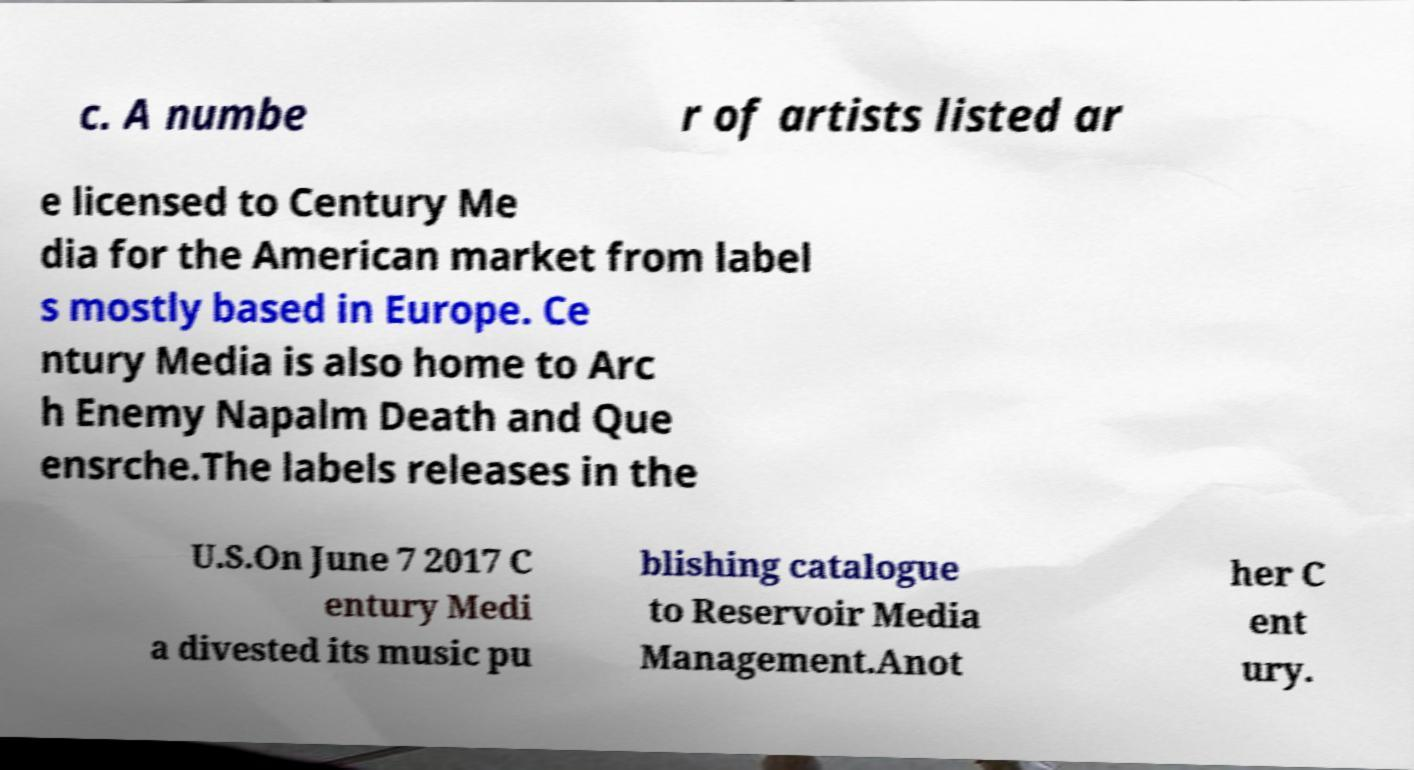Please identify and transcribe the text found in this image. c. A numbe r of artists listed ar e licensed to Century Me dia for the American market from label s mostly based in Europe. Ce ntury Media is also home to Arc h Enemy Napalm Death and Que ensrche.The labels releases in the U.S.On June 7 2017 C entury Medi a divested its music pu blishing catalogue to Reservoir Media Management.Anot her C ent ury. 